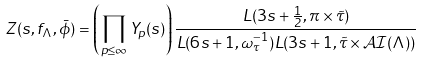Convert formula to latex. <formula><loc_0><loc_0><loc_500><loc_500>Z ( s , f _ { \Lambda } , \bar { \phi } ) = \left ( \prod _ { p \leq \infty } Y _ { p } ( s ) \right ) \frac { L ( 3 s + \frac { 1 } { 2 } , \pi \times \tilde { \tau } ) } { L ( 6 s + 1 , \omega _ { \tau } ^ { - 1 } ) L ( 3 s + 1 , \tilde { \tau } \times \mathcal { A I } ( \Lambda ) ) }</formula> 